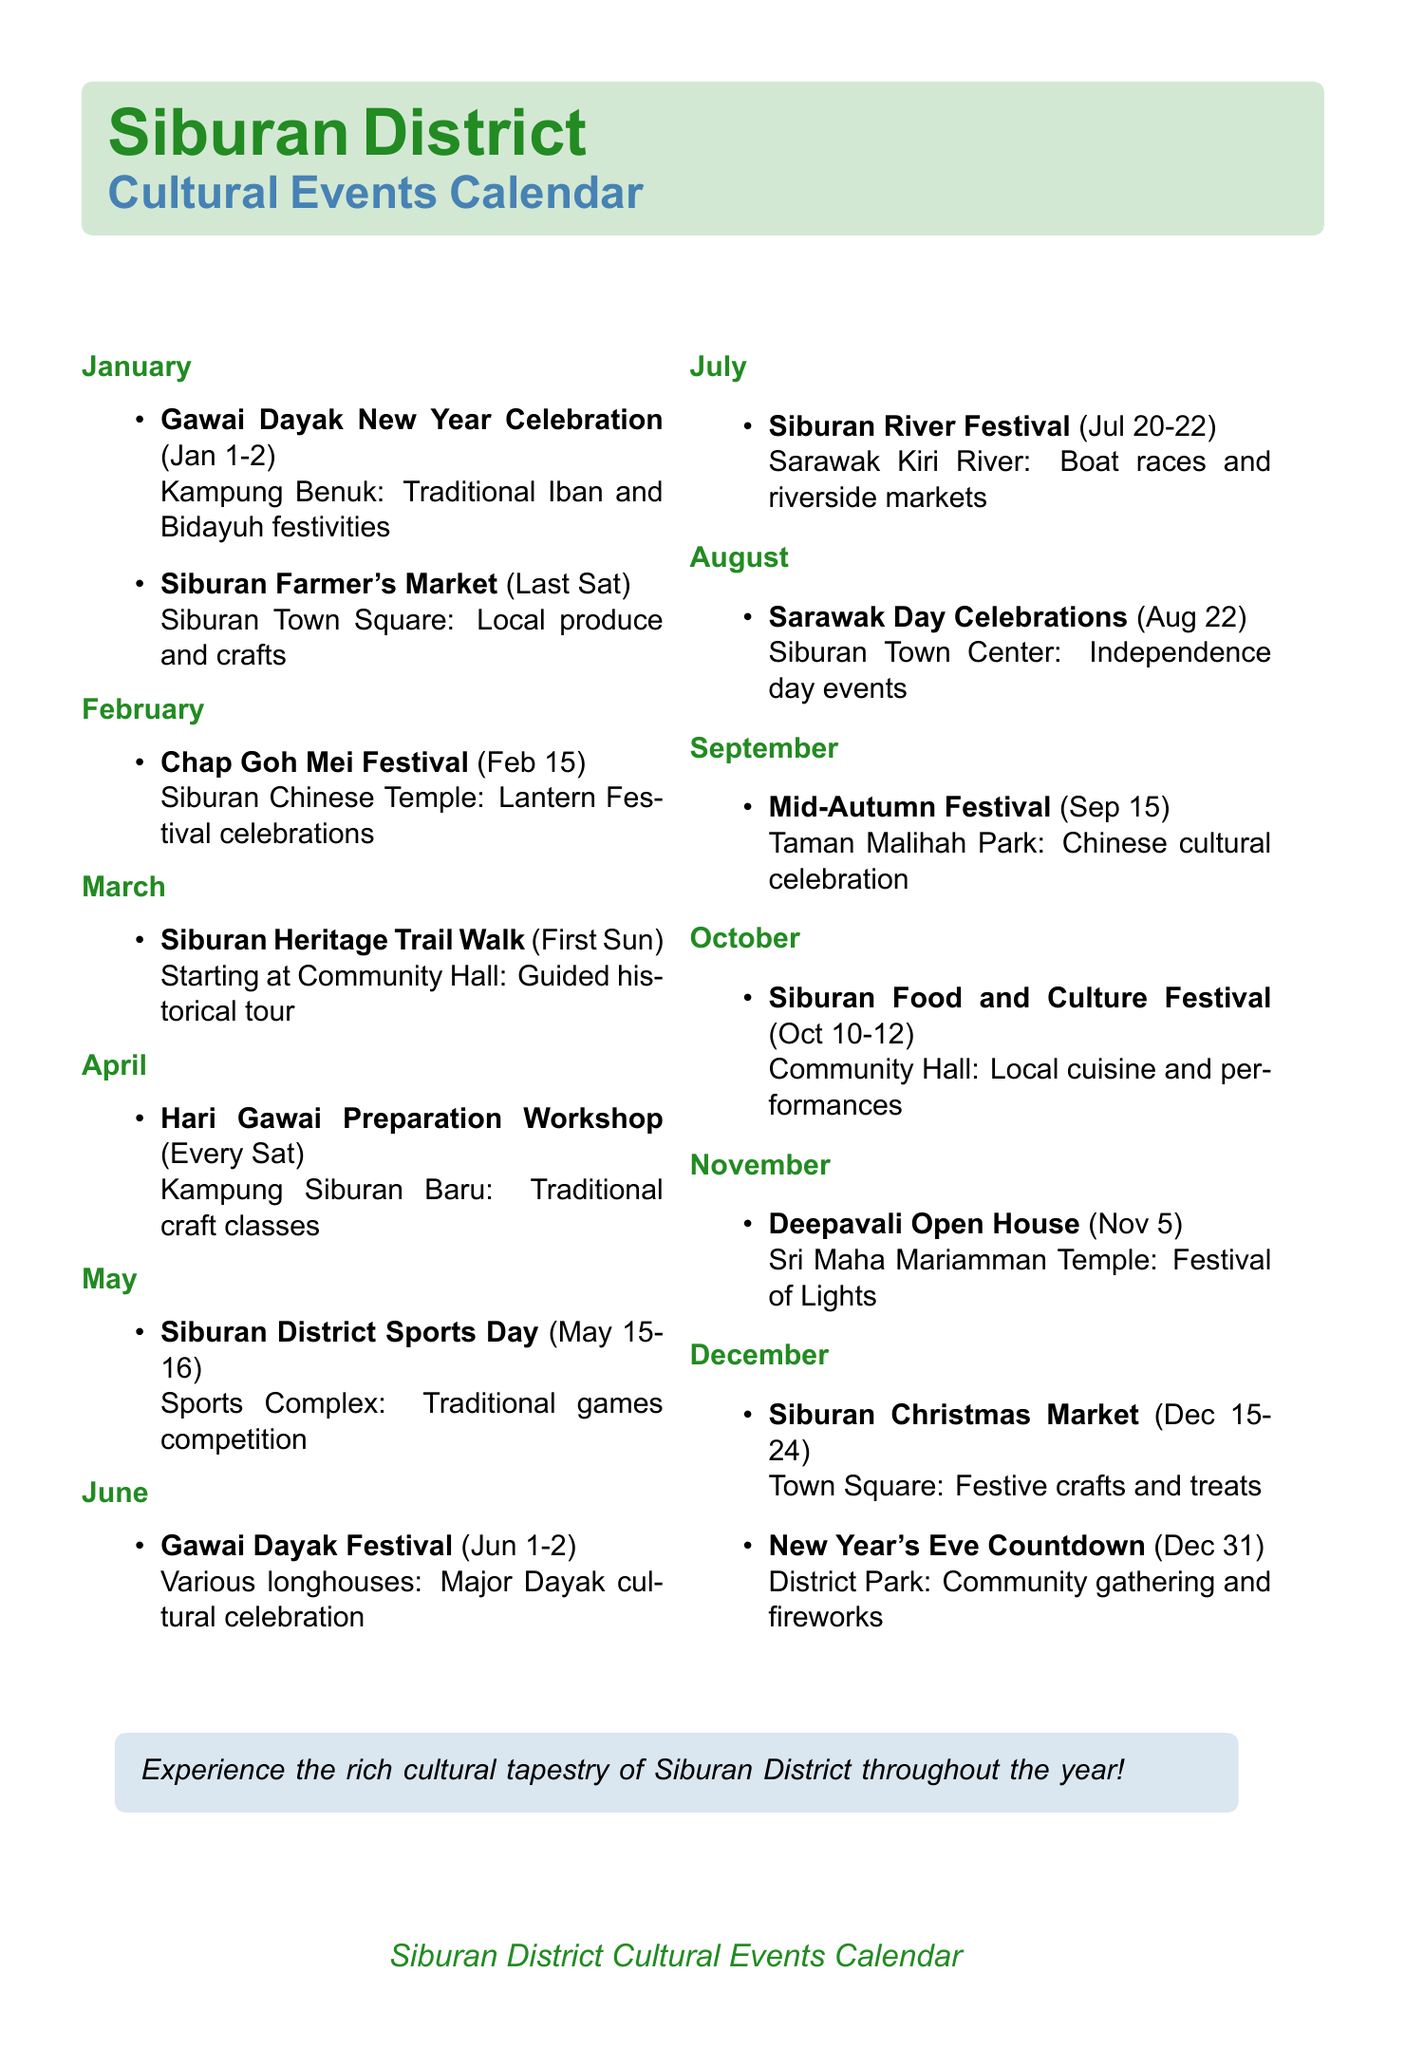What is the event celebrated on January 1-2? The document mentions "Gawai Dayak New Year Celebration" as the event during this date.
Answer: Gawai Dayak New Year Celebration Where is the Siburan Farmer's Market held? According to the document, the location for the Siburan Farmer's Market is "Siburan Town Square."
Answer: Siburan Town Square What type of performances are featured at the Chap Goh Mei Festival? The festival features "lion dances, lantern parades, and traditional performances" as stated in the document.
Answer: Lion dances, lantern parades, and traditional performances When is the Deepavali Open House celebrated? The document specifically states that the Deepavali Open House occurs on "November 5."
Answer: November 5 How many days does the Siburan Christmas Market run? The document lists the dates for the Christmas Market as "December 15-24," indicating a span of 10 days.
Answer: 10 days Which festival includes traditional craft and cooking classes? The "Hari Gawai Preparation Workshop" is mentioned as including traditional craft and cooking classes.
Answer: Hari Gawai Preparation Workshop What is the main focus of the Siburan River Festival? The document notes that the event celebrates local waterways with "boat races, fishing competitions, and riverside markets."
Answer: Boat races, fishing competitions, and riverside markets On what date is the Mid-Autumn Festival celebrated? The document states that the Mid-Autumn Festival takes place on "September 15."
Answer: September 15 